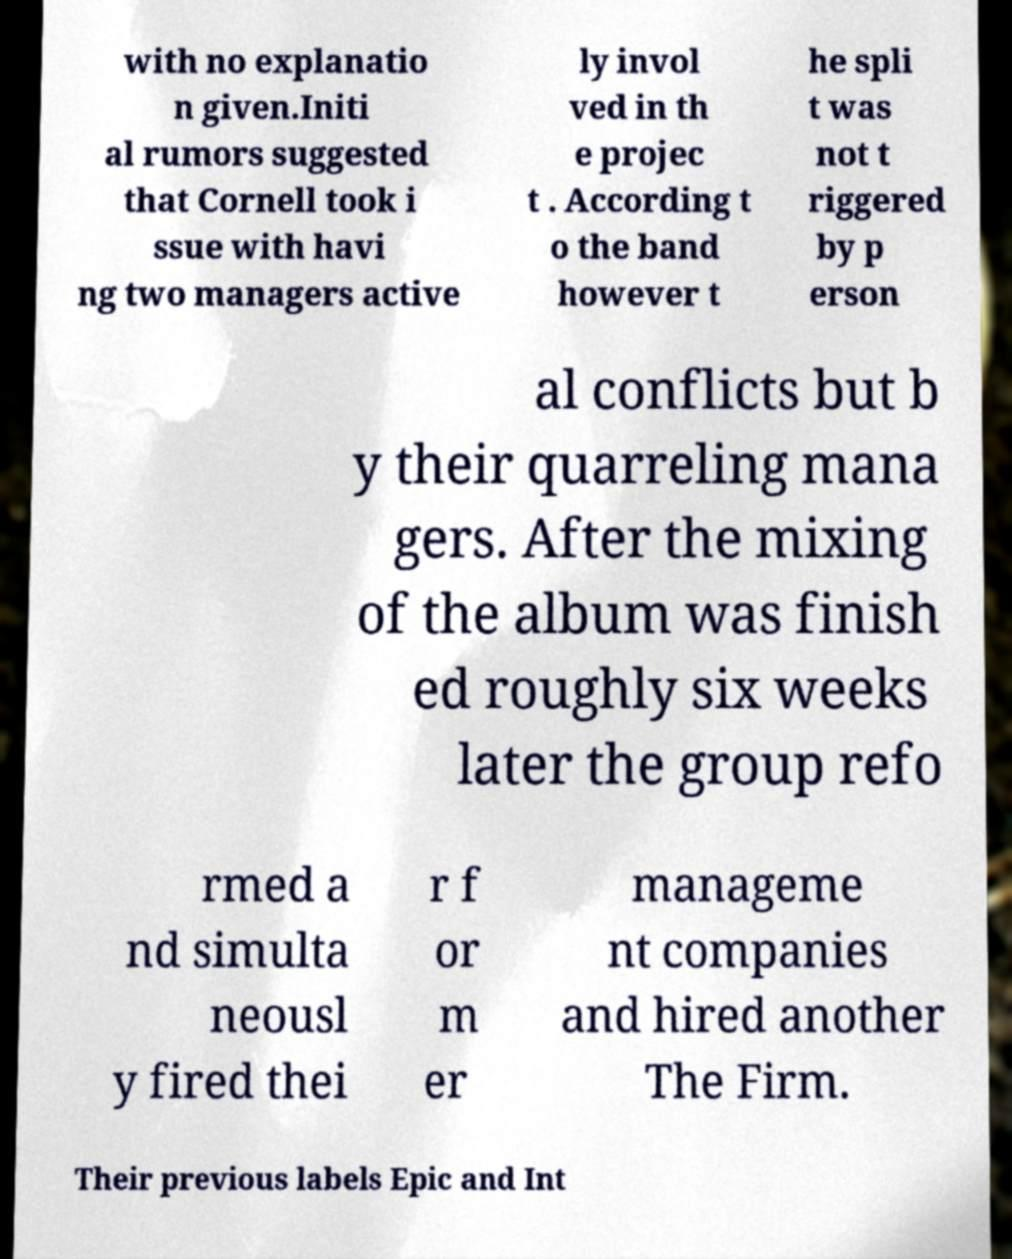What messages or text are displayed in this image? I need them in a readable, typed format. with no explanatio n given.Initi al rumors suggested that Cornell took i ssue with havi ng two managers active ly invol ved in th e projec t . According t o the band however t he spli t was not t riggered by p erson al conflicts but b y their quarreling mana gers. After the mixing of the album was finish ed roughly six weeks later the group refo rmed a nd simulta neousl y fired thei r f or m er manageme nt companies and hired another The Firm. Their previous labels Epic and Int 